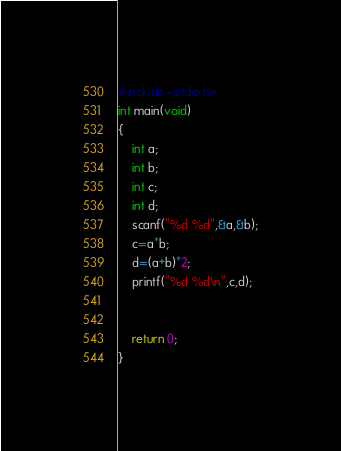Convert code to text. <code><loc_0><loc_0><loc_500><loc_500><_C_>#include <stdio.h>
int main(void)
{
	int a;
	int b;
	int c;
	int d;
	scanf("%d %d",&a,&b);
	c=a*b;
	d=(a+b)*2;
	printf("%d %d\n",c,d);


	return 0;
}</code> 